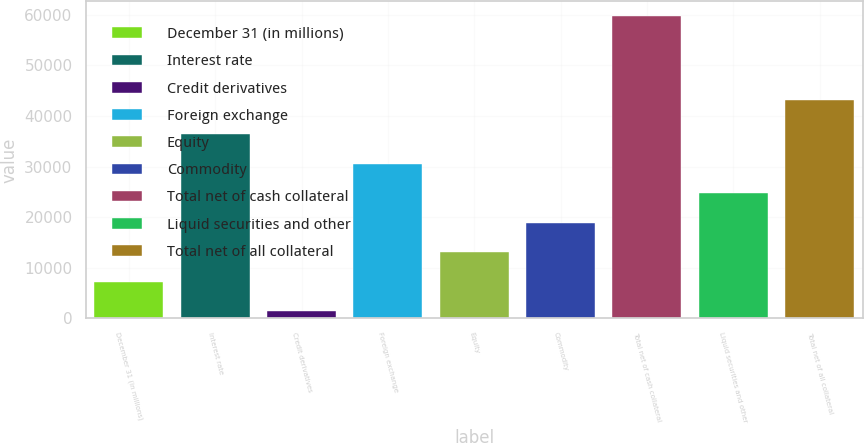<chart> <loc_0><loc_0><loc_500><loc_500><bar_chart><fcel>December 31 (in millions)<fcel>Interest rate<fcel>Credit derivatives<fcel>Foreign exchange<fcel>Equity<fcel>Commodity<fcel>Total net of cash collateral<fcel>Liquid securities and other<fcel>Total net of all collateral<nl><fcel>7248.4<fcel>36375.4<fcel>1423<fcel>30550<fcel>13073.8<fcel>18899.2<fcel>59677<fcel>24724.6<fcel>43097<nl></chart> 